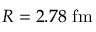Convert formula to latex. <formula><loc_0><loc_0><loc_500><loc_500>R = 2 . 7 8 \ f m</formula> 